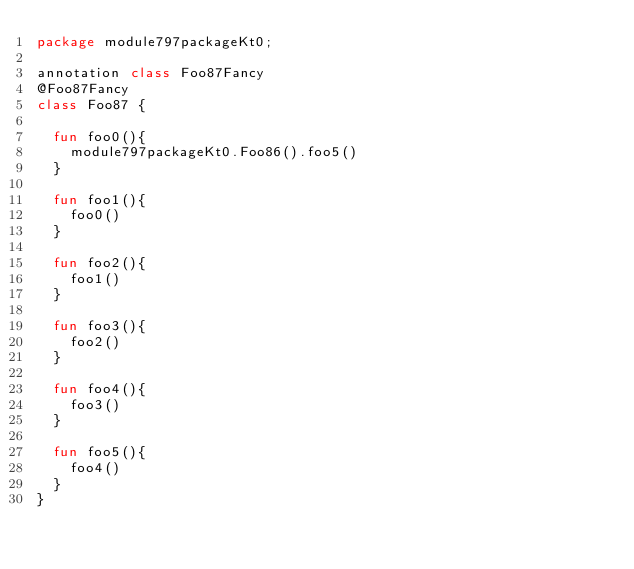<code> <loc_0><loc_0><loc_500><loc_500><_Kotlin_>package module797packageKt0;

annotation class Foo87Fancy
@Foo87Fancy
class Foo87 {

  fun foo0(){
    module797packageKt0.Foo86().foo5()
  }

  fun foo1(){
    foo0()
  }

  fun foo2(){
    foo1()
  }

  fun foo3(){
    foo2()
  }

  fun foo4(){
    foo3()
  }

  fun foo5(){
    foo4()
  }
}</code> 